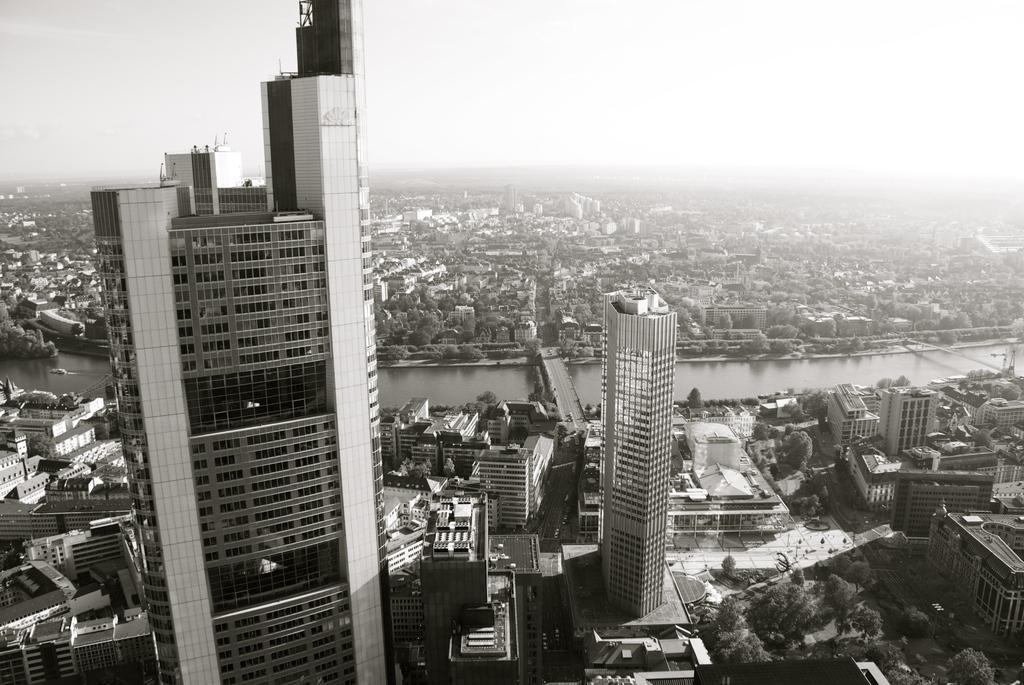Please provide a concise description of this image. Here we can see buildings, trees, water and bridge. Buildings with windows. 